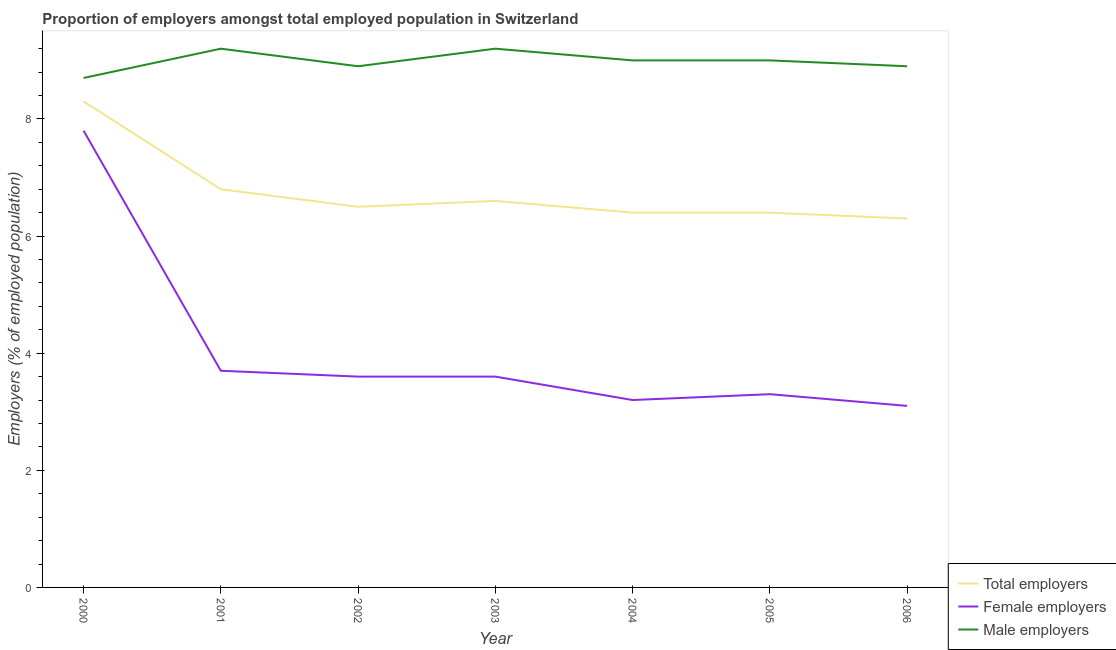How many different coloured lines are there?
Offer a very short reply. 3. What is the percentage of male employers in 2001?
Keep it short and to the point. 9.2. Across all years, what is the maximum percentage of female employers?
Offer a terse response. 7.8. Across all years, what is the minimum percentage of male employers?
Offer a very short reply. 8.7. What is the total percentage of male employers in the graph?
Ensure brevity in your answer.  62.9. What is the difference between the percentage of total employers in 2003 and that in 2005?
Offer a terse response. 0.2. What is the difference between the percentage of female employers in 2006 and the percentage of total employers in 2000?
Keep it short and to the point. -5.2. What is the average percentage of male employers per year?
Give a very brief answer. 8.99. In the year 2004, what is the difference between the percentage of female employers and percentage of male employers?
Keep it short and to the point. -5.8. In how many years, is the percentage of female employers greater than 0.4 %?
Your answer should be very brief. 7. What is the ratio of the percentage of total employers in 2002 to that in 2003?
Make the answer very short. 0.98. Is the percentage of male employers in 2000 less than that in 2003?
Provide a short and direct response. Yes. What is the difference between the highest and the second highest percentage of total employers?
Ensure brevity in your answer.  1.5. What is the difference between the highest and the lowest percentage of female employers?
Your answer should be compact. 4.7. In how many years, is the percentage of male employers greater than the average percentage of male employers taken over all years?
Your response must be concise. 4. Does the percentage of female employers monotonically increase over the years?
Your answer should be very brief. No. Is the percentage of male employers strictly greater than the percentage of total employers over the years?
Your answer should be very brief. Yes. Is the percentage of total employers strictly less than the percentage of male employers over the years?
Provide a short and direct response. Yes. How many lines are there?
Keep it short and to the point. 3. What is the difference between two consecutive major ticks on the Y-axis?
Offer a very short reply. 2. Are the values on the major ticks of Y-axis written in scientific E-notation?
Make the answer very short. No. How are the legend labels stacked?
Your response must be concise. Vertical. What is the title of the graph?
Your answer should be compact. Proportion of employers amongst total employed population in Switzerland. Does "Ireland" appear as one of the legend labels in the graph?
Offer a terse response. No. What is the label or title of the Y-axis?
Keep it short and to the point. Employers (% of employed population). What is the Employers (% of employed population) of Total employers in 2000?
Provide a succinct answer. 8.3. What is the Employers (% of employed population) of Female employers in 2000?
Offer a very short reply. 7.8. What is the Employers (% of employed population) in Male employers in 2000?
Give a very brief answer. 8.7. What is the Employers (% of employed population) of Total employers in 2001?
Offer a very short reply. 6.8. What is the Employers (% of employed population) in Female employers in 2001?
Provide a succinct answer. 3.7. What is the Employers (% of employed population) of Male employers in 2001?
Give a very brief answer. 9.2. What is the Employers (% of employed population) in Female employers in 2002?
Your answer should be very brief. 3.6. What is the Employers (% of employed population) in Male employers in 2002?
Give a very brief answer. 8.9. What is the Employers (% of employed population) of Total employers in 2003?
Your answer should be compact. 6.6. What is the Employers (% of employed population) in Female employers in 2003?
Provide a succinct answer. 3.6. What is the Employers (% of employed population) of Male employers in 2003?
Ensure brevity in your answer.  9.2. What is the Employers (% of employed population) in Total employers in 2004?
Give a very brief answer. 6.4. What is the Employers (% of employed population) of Female employers in 2004?
Provide a short and direct response. 3.2. What is the Employers (% of employed population) in Male employers in 2004?
Your answer should be compact. 9. What is the Employers (% of employed population) in Total employers in 2005?
Ensure brevity in your answer.  6.4. What is the Employers (% of employed population) in Female employers in 2005?
Keep it short and to the point. 3.3. What is the Employers (% of employed population) of Total employers in 2006?
Ensure brevity in your answer.  6.3. What is the Employers (% of employed population) of Female employers in 2006?
Provide a short and direct response. 3.1. What is the Employers (% of employed population) of Male employers in 2006?
Offer a terse response. 8.9. Across all years, what is the maximum Employers (% of employed population) in Total employers?
Your response must be concise. 8.3. Across all years, what is the maximum Employers (% of employed population) in Female employers?
Your answer should be compact. 7.8. Across all years, what is the maximum Employers (% of employed population) of Male employers?
Your answer should be very brief. 9.2. Across all years, what is the minimum Employers (% of employed population) of Total employers?
Your answer should be compact. 6.3. Across all years, what is the minimum Employers (% of employed population) in Female employers?
Your answer should be compact. 3.1. Across all years, what is the minimum Employers (% of employed population) of Male employers?
Give a very brief answer. 8.7. What is the total Employers (% of employed population) of Total employers in the graph?
Keep it short and to the point. 47.3. What is the total Employers (% of employed population) of Female employers in the graph?
Offer a very short reply. 28.3. What is the total Employers (% of employed population) in Male employers in the graph?
Keep it short and to the point. 62.9. What is the difference between the Employers (% of employed population) in Total employers in 2000 and that in 2001?
Provide a succinct answer. 1.5. What is the difference between the Employers (% of employed population) in Total employers in 2000 and that in 2002?
Give a very brief answer. 1.8. What is the difference between the Employers (% of employed population) in Female employers in 2000 and that in 2002?
Provide a succinct answer. 4.2. What is the difference between the Employers (% of employed population) of Total employers in 2000 and that in 2003?
Provide a short and direct response. 1.7. What is the difference between the Employers (% of employed population) in Female employers in 2000 and that in 2004?
Offer a terse response. 4.6. What is the difference between the Employers (% of employed population) in Male employers in 2000 and that in 2004?
Give a very brief answer. -0.3. What is the difference between the Employers (% of employed population) of Total employers in 2000 and that in 2005?
Offer a very short reply. 1.9. What is the difference between the Employers (% of employed population) of Female employers in 2000 and that in 2005?
Provide a short and direct response. 4.5. What is the difference between the Employers (% of employed population) of Total employers in 2000 and that in 2006?
Keep it short and to the point. 2. What is the difference between the Employers (% of employed population) of Female employers in 2000 and that in 2006?
Your response must be concise. 4.7. What is the difference between the Employers (% of employed population) of Male employers in 2000 and that in 2006?
Offer a very short reply. -0.2. What is the difference between the Employers (% of employed population) in Total employers in 2001 and that in 2002?
Offer a very short reply. 0.3. What is the difference between the Employers (% of employed population) of Male employers in 2001 and that in 2002?
Keep it short and to the point. 0.3. What is the difference between the Employers (% of employed population) in Total employers in 2001 and that in 2003?
Keep it short and to the point. 0.2. What is the difference between the Employers (% of employed population) in Female employers in 2001 and that in 2003?
Your answer should be very brief. 0.1. What is the difference between the Employers (% of employed population) of Male employers in 2001 and that in 2003?
Give a very brief answer. 0. What is the difference between the Employers (% of employed population) in Female employers in 2001 and that in 2004?
Provide a short and direct response. 0.5. What is the difference between the Employers (% of employed population) of Total employers in 2001 and that in 2005?
Make the answer very short. 0.4. What is the difference between the Employers (% of employed population) in Total employers in 2001 and that in 2006?
Give a very brief answer. 0.5. What is the difference between the Employers (% of employed population) of Female employers in 2001 and that in 2006?
Your answer should be compact. 0.6. What is the difference between the Employers (% of employed population) in Total employers in 2002 and that in 2003?
Give a very brief answer. -0.1. What is the difference between the Employers (% of employed population) in Female employers in 2002 and that in 2003?
Provide a succinct answer. 0. What is the difference between the Employers (% of employed population) of Male employers in 2002 and that in 2003?
Your response must be concise. -0.3. What is the difference between the Employers (% of employed population) in Female employers in 2002 and that in 2004?
Make the answer very short. 0.4. What is the difference between the Employers (% of employed population) in Male employers in 2002 and that in 2004?
Provide a short and direct response. -0.1. What is the difference between the Employers (% of employed population) of Total employers in 2002 and that in 2005?
Offer a terse response. 0.1. What is the difference between the Employers (% of employed population) of Female employers in 2002 and that in 2005?
Your response must be concise. 0.3. What is the difference between the Employers (% of employed population) of Female employers in 2002 and that in 2006?
Your answer should be very brief. 0.5. What is the difference between the Employers (% of employed population) of Male employers in 2002 and that in 2006?
Offer a terse response. 0. What is the difference between the Employers (% of employed population) of Total employers in 2003 and that in 2005?
Your response must be concise. 0.2. What is the difference between the Employers (% of employed population) of Female employers in 2003 and that in 2005?
Ensure brevity in your answer.  0.3. What is the difference between the Employers (% of employed population) in Male employers in 2003 and that in 2005?
Your response must be concise. 0.2. What is the difference between the Employers (% of employed population) in Total employers in 2003 and that in 2006?
Your response must be concise. 0.3. What is the difference between the Employers (% of employed population) in Total employers in 2004 and that in 2005?
Keep it short and to the point. 0. What is the difference between the Employers (% of employed population) in Male employers in 2004 and that in 2005?
Offer a very short reply. 0. What is the difference between the Employers (% of employed population) of Total employers in 2004 and that in 2006?
Offer a very short reply. 0.1. What is the difference between the Employers (% of employed population) of Female employers in 2004 and that in 2006?
Provide a short and direct response. 0.1. What is the difference between the Employers (% of employed population) of Male employers in 2004 and that in 2006?
Give a very brief answer. 0.1. What is the difference between the Employers (% of employed population) in Total employers in 2005 and that in 2006?
Offer a very short reply. 0.1. What is the difference between the Employers (% of employed population) in Female employers in 2005 and that in 2006?
Provide a succinct answer. 0.2. What is the difference between the Employers (% of employed population) of Male employers in 2005 and that in 2006?
Provide a succinct answer. 0.1. What is the difference between the Employers (% of employed population) of Total employers in 2000 and the Employers (% of employed population) of Female employers in 2001?
Offer a terse response. 4.6. What is the difference between the Employers (% of employed population) in Female employers in 2000 and the Employers (% of employed population) in Male employers in 2001?
Make the answer very short. -1.4. What is the difference between the Employers (% of employed population) of Total employers in 2000 and the Employers (% of employed population) of Female employers in 2003?
Your answer should be compact. 4.7. What is the difference between the Employers (% of employed population) in Total employers in 2000 and the Employers (% of employed population) in Male employers in 2005?
Make the answer very short. -0.7. What is the difference between the Employers (% of employed population) of Total employers in 2000 and the Employers (% of employed population) of Female employers in 2006?
Provide a short and direct response. 5.2. What is the difference between the Employers (% of employed population) of Female employers in 2000 and the Employers (% of employed population) of Male employers in 2006?
Offer a terse response. -1.1. What is the difference between the Employers (% of employed population) in Total employers in 2001 and the Employers (% of employed population) in Female employers in 2002?
Provide a short and direct response. 3.2. What is the difference between the Employers (% of employed population) in Total employers in 2001 and the Employers (% of employed population) in Male employers in 2002?
Keep it short and to the point. -2.1. What is the difference between the Employers (% of employed population) of Female employers in 2001 and the Employers (% of employed population) of Male employers in 2002?
Keep it short and to the point. -5.2. What is the difference between the Employers (% of employed population) of Total employers in 2001 and the Employers (% of employed population) of Male employers in 2003?
Your answer should be very brief. -2.4. What is the difference between the Employers (% of employed population) of Female employers in 2001 and the Employers (% of employed population) of Male employers in 2003?
Offer a terse response. -5.5. What is the difference between the Employers (% of employed population) of Total employers in 2001 and the Employers (% of employed population) of Female employers in 2004?
Provide a succinct answer. 3.6. What is the difference between the Employers (% of employed population) in Female employers in 2001 and the Employers (% of employed population) in Male employers in 2004?
Provide a succinct answer. -5.3. What is the difference between the Employers (% of employed population) of Total employers in 2001 and the Employers (% of employed population) of Female employers in 2005?
Keep it short and to the point. 3.5. What is the difference between the Employers (% of employed population) in Total employers in 2001 and the Employers (% of employed population) in Male employers in 2005?
Your answer should be very brief. -2.2. What is the difference between the Employers (% of employed population) in Total employers in 2001 and the Employers (% of employed population) in Male employers in 2006?
Your answer should be compact. -2.1. What is the difference between the Employers (% of employed population) of Female employers in 2001 and the Employers (% of employed population) of Male employers in 2006?
Keep it short and to the point. -5.2. What is the difference between the Employers (% of employed population) in Total employers in 2002 and the Employers (% of employed population) in Female employers in 2003?
Keep it short and to the point. 2.9. What is the difference between the Employers (% of employed population) in Female employers in 2002 and the Employers (% of employed population) in Male employers in 2003?
Keep it short and to the point. -5.6. What is the difference between the Employers (% of employed population) in Total employers in 2002 and the Employers (% of employed population) in Female employers in 2004?
Provide a succinct answer. 3.3. What is the difference between the Employers (% of employed population) in Total employers in 2002 and the Employers (% of employed population) in Male employers in 2004?
Your answer should be very brief. -2.5. What is the difference between the Employers (% of employed population) of Total employers in 2002 and the Employers (% of employed population) of Female employers in 2005?
Offer a very short reply. 3.2. What is the difference between the Employers (% of employed population) of Female employers in 2002 and the Employers (% of employed population) of Male employers in 2006?
Your answer should be very brief. -5.3. What is the difference between the Employers (% of employed population) in Total employers in 2003 and the Employers (% of employed population) in Female employers in 2005?
Make the answer very short. 3.3. What is the difference between the Employers (% of employed population) in Total employers in 2004 and the Employers (% of employed population) in Female employers in 2005?
Provide a short and direct response. 3.1. What is the difference between the Employers (% of employed population) of Total employers in 2005 and the Employers (% of employed population) of Male employers in 2006?
Make the answer very short. -2.5. What is the difference between the Employers (% of employed population) in Female employers in 2005 and the Employers (% of employed population) in Male employers in 2006?
Offer a terse response. -5.6. What is the average Employers (% of employed population) in Total employers per year?
Provide a short and direct response. 6.76. What is the average Employers (% of employed population) of Female employers per year?
Give a very brief answer. 4.04. What is the average Employers (% of employed population) of Male employers per year?
Ensure brevity in your answer.  8.99. In the year 2000, what is the difference between the Employers (% of employed population) in Female employers and Employers (% of employed population) in Male employers?
Your answer should be very brief. -0.9. In the year 2001, what is the difference between the Employers (% of employed population) of Total employers and Employers (% of employed population) of Female employers?
Offer a very short reply. 3.1. In the year 2001, what is the difference between the Employers (% of employed population) of Total employers and Employers (% of employed population) of Male employers?
Your response must be concise. -2.4. In the year 2001, what is the difference between the Employers (% of employed population) of Female employers and Employers (% of employed population) of Male employers?
Keep it short and to the point. -5.5. In the year 2002, what is the difference between the Employers (% of employed population) of Total employers and Employers (% of employed population) of Female employers?
Make the answer very short. 2.9. In the year 2002, what is the difference between the Employers (% of employed population) in Total employers and Employers (% of employed population) in Male employers?
Your answer should be compact. -2.4. In the year 2003, what is the difference between the Employers (% of employed population) in Total employers and Employers (% of employed population) in Female employers?
Make the answer very short. 3. In the year 2003, what is the difference between the Employers (% of employed population) of Total employers and Employers (% of employed population) of Male employers?
Offer a terse response. -2.6. In the year 2003, what is the difference between the Employers (% of employed population) of Female employers and Employers (% of employed population) of Male employers?
Offer a terse response. -5.6. In the year 2004, what is the difference between the Employers (% of employed population) of Total employers and Employers (% of employed population) of Male employers?
Offer a very short reply. -2.6. In the year 2005, what is the difference between the Employers (% of employed population) in Total employers and Employers (% of employed population) in Female employers?
Give a very brief answer. 3.1. In the year 2005, what is the difference between the Employers (% of employed population) of Total employers and Employers (% of employed population) of Male employers?
Provide a short and direct response. -2.6. In the year 2005, what is the difference between the Employers (% of employed population) of Female employers and Employers (% of employed population) of Male employers?
Provide a succinct answer. -5.7. In the year 2006, what is the difference between the Employers (% of employed population) of Total employers and Employers (% of employed population) of Male employers?
Give a very brief answer. -2.6. In the year 2006, what is the difference between the Employers (% of employed population) of Female employers and Employers (% of employed population) of Male employers?
Offer a very short reply. -5.8. What is the ratio of the Employers (% of employed population) of Total employers in 2000 to that in 2001?
Your response must be concise. 1.22. What is the ratio of the Employers (% of employed population) of Female employers in 2000 to that in 2001?
Give a very brief answer. 2.11. What is the ratio of the Employers (% of employed population) of Male employers in 2000 to that in 2001?
Make the answer very short. 0.95. What is the ratio of the Employers (% of employed population) in Total employers in 2000 to that in 2002?
Provide a short and direct response. 1.28. What is the ratio of the Employers (% of employed population) in Female employers in 2000 to that in 2002?
Provide a short and direct response. 2.17. What is the ratio of the Employers (% of employed population) of Male employers in 2000 to that in 2002?
Ensure brevity in your answer.  0.98. What is the ratio of the Employers (% of employed population) in Total employers in 2000 to that in 2003?
Keep it short and to the point. 1.26. What is the ratio of the Employers (% of employed population) of Female employers in 2000 to that in 2003?
Your response must be concise. 2.17. What is the ratio of the Employers (% of employed population) in Male employers in 2000 to that in 2003?
Your answer should be very brief. 0.95. What is the ratio of the Employers (% of employed population) in Total employers in 2000 to that in 2004?
Keep it short and to the point. 1.3. What is the ratio of the Employers (% of employed population) of Female employers in 2000 to that in 2004?
Give a very brief answer. 2.44. What is the ratio of the Employers (% of employed population) in Male employers in 2000 to that in 2004?
Provide a succinct answer. 0.97. What is the ratio of the Employers (% of employed population) of Total employers in 2000 to that in 2005?
Offer a very short reply. 1.3. What is the ratio of the Employers (% of employed population) of Female employers in 2000 to that in 2005?
Keep it short and to the point. 2.36. What is the ratio of the Employers (% of employed population) of Male employers in 2000 to that in 2005?
Make the answer very short. 0.97. What is the ratio of the Employers (% of employed population) of Total employers in 2000 to that in 2006?
Provide a short and direct response. 1.32. What is the ratio of the Employers (% of employed population) in Female employers in 2000 to that in 2006?
Offer a terse response. 2.52. What is the ratio of the Employers (% of employed population) of Male employers in 2000 to that in 2006?
Keep it short and to the point. 0.98. What is the ratio of the Employers (% of employed population) in Total employers in 2001 to that in 2002?
Ensure brevity in your answer.  1.05. What is the ratio of the Employers (% of employed population) in Female employers in 2001 to that in 2002?
Your response must be concise. 1.03. What is the ratio of the Employers (% of employed population) of Male employers in 2001 to that in 2002?
Ensure brevity in your answer.  1.03. What is the ratio of the Employers (% of employed population) in Total employers in 2001 to that in 2003?
Give a very brief answer. 1.03. What is the ratio of the Employers (% of employed population) in Female employers in 2001 to that in 2003?
Provide a short and direct response. 1.03. What is the ratio of the Employers (% of employed population) of Female employers in 2001 to that in 2004?
Provide a succinct answer. 1.16. What is the ratio of the Employers (% of employed population) of Male employers in 2001 to that in 2004?
Provide a short and direct response. 1.02. What is the ratio of the Employers (% of employed population) of Female employers in 2001 to that in 2005?
Your answer should be very brief. 1.12. What is the ratio of the Employers (% of employed population) of Male employers in 2001 to that in 2005?
Your answer should be compact. 1.02. What is the ratio of the Employers (% of employed population) of Total employers in 2001 to that in 2006?
Keep it short and to the point. 1.08. What is the ratio of the Employers (% of employed population) in Female employers in 2001 to that in 2006?
Your response must be concise. 1.19. What is the ratio of the Employers (% of employed population) of Male employers in 2001 to that in 2006?
Offer a terse response. 1.03. What is the ratio of the Employers (% of employed population) of Male employers in 2002 to that in 2003?
Keep it short and to the point. 0.97. What is the ratio of the Employers (% of employed population) in Total employers in 2002 to that in 2004?
Keep it short and to the point. 1.02. What is the ratio of the Employers (% of employed population) of Female employers in 2002 to that in 2004?
Make the answer very short. 1.12. What is the ratio of the Employers (% of employed population) of Male employers in 2002 to that in 2004?
Your answer should be very brief. 0.99. What is the ratio of the Employers (% of employed population) in Total employers in 2002 to that in 2005?
Provide a short and direct response. 1.02. What is the ratio of the Employers (% of employed population) of Male employers in 2002 to that in 2005?
Offer a terse response. 0.99. What is the ratio of the Employers (% of employed population) of Total employers in 2002 to that in 2006?
Offer a very short reply. 1.03. What is the ratio of the Employers (% of employed population) in Female employers in 2002 to that in 2006?
Give a very brief answer. 1.16. What is the ratio of the Employers (% of employed population) in Total employers in 2003 to that in 2004?
Provide a short and direct response. 1.03. What is the ratio of the Employers (% of employed population) in Male employers in 2003 to that in 2004?
Offer a very short reply. 1.02. What is the ratio of the Employers (% of employed population) in Total employers in 2003 to that in 2005?
Offer a very short reply. 1.03. What is the ratio of the Employers (% of employed population) in Male employers in 2003 to that in 2005?
Offer a very short reply. 1.02. What is the ratio of the Employers (% of employed population) of Total employers in 2003 to that in 2006?
Your response must be concise. 1.05. What is the ratio of the Employers (% of employed population) of Female employers in 2003 to that in 2006?
Offer a very short reply. 1.16. What is the ratio of the Employers (% of employed population) in Male employers in 2003 to that in 2006?
Provide a short and direct response. 1.03. What is the ratio of the Employers (% of employed population) in Female employers in 2004 to that in 2005?
Ensure brevity in your answer.  0.97. What is the ratio of the Employers (% of employed population) in Male employers in 2004 to that in 2005?
Offer a very short reply. 1. What is the ratio of the Employers (% of employed population) in Total employers in 2004 to that in 2006?
Make the answer very short. 1.02. What is the ratio of the Employers (% of employed population) in Female employers in 2004 to that in 2006?
Offer a terse response. 1.03. What is the ratio of the Employers (% of employed population) in Male employers in 2004 to that in 2006?
Give a very brief answer. 1.01. What is the ratio of the Employers (% of employed population) in Total employers in 2005 to that in 2006?
Your answer should be very brief. 1.02. What is the ratio of the Employers (% of employed population) in Female employers in 2005 to that in 2006?
Keep it short and to the point. 1.06. What is the ratio of the Employers (% of employed population) in Male employers in 2005 to that in 2006?
Provide a short and direct response. 1.01. What is the difference between the highest and the second highest Employers (% of employed population) of Total employers?
Your answer should be very brief. 1.5. What is the difference between the highest and the second highest Employers (% of employed population) of Female employers?
Make the answer very short. 4.1. What is the difference between the highest and the lowest Employers (% of employed population) in Total employers?
Ensure brevity in your answer.  2. What is the difference between the highest and the lowest Employers (% of employed population) of Female employers?
Give a very brief answer. 4.7. 